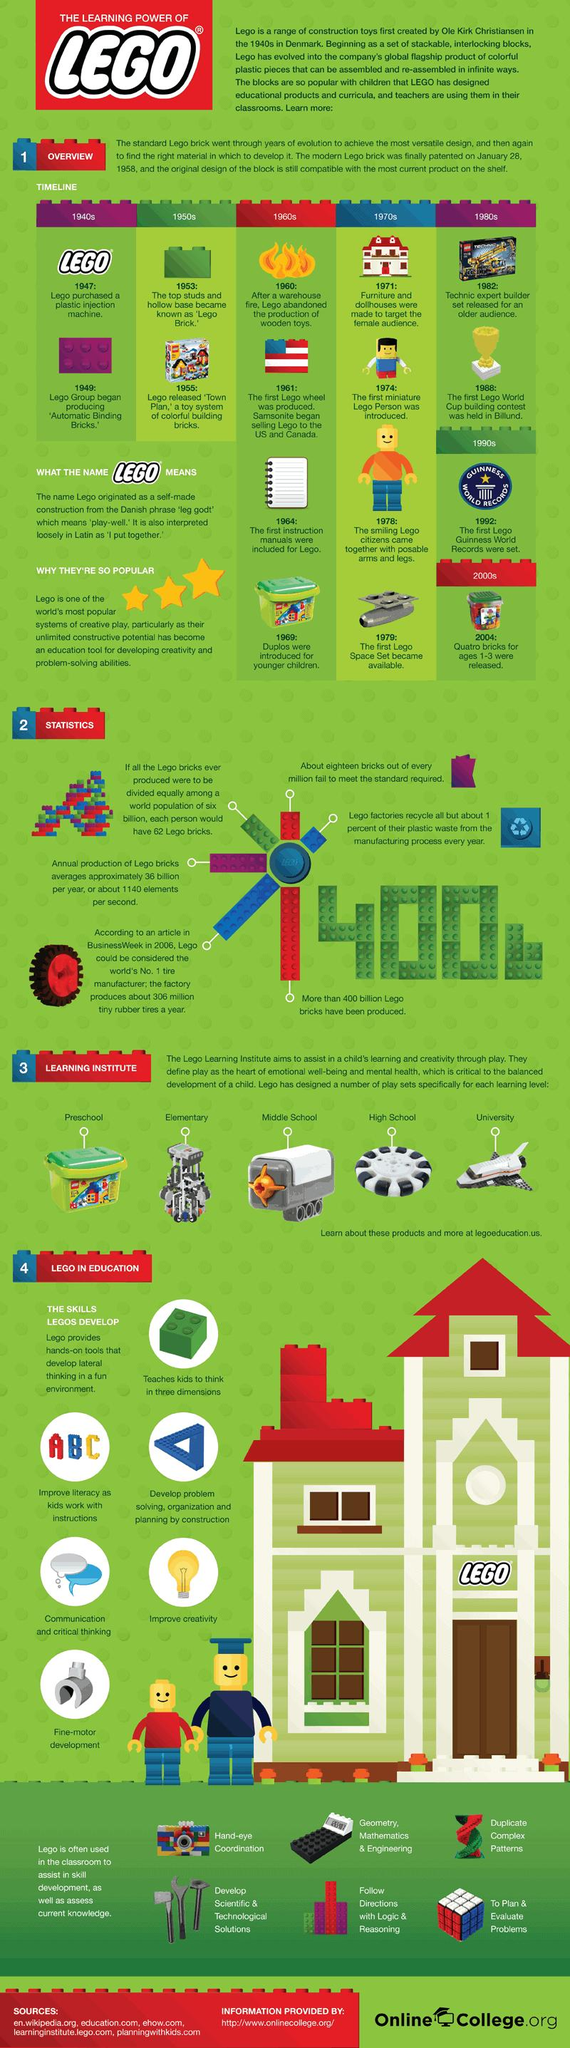Draw attention to some important aspects in this diagram. In 1940, the Lego was invented. The first Lego Guinness World Record was set in the year 1992. Lego began including manuals with their products in the year 1964. The first Lego Space Set was released in 1979. The inaugural Lego World Cup was held in 1988. 